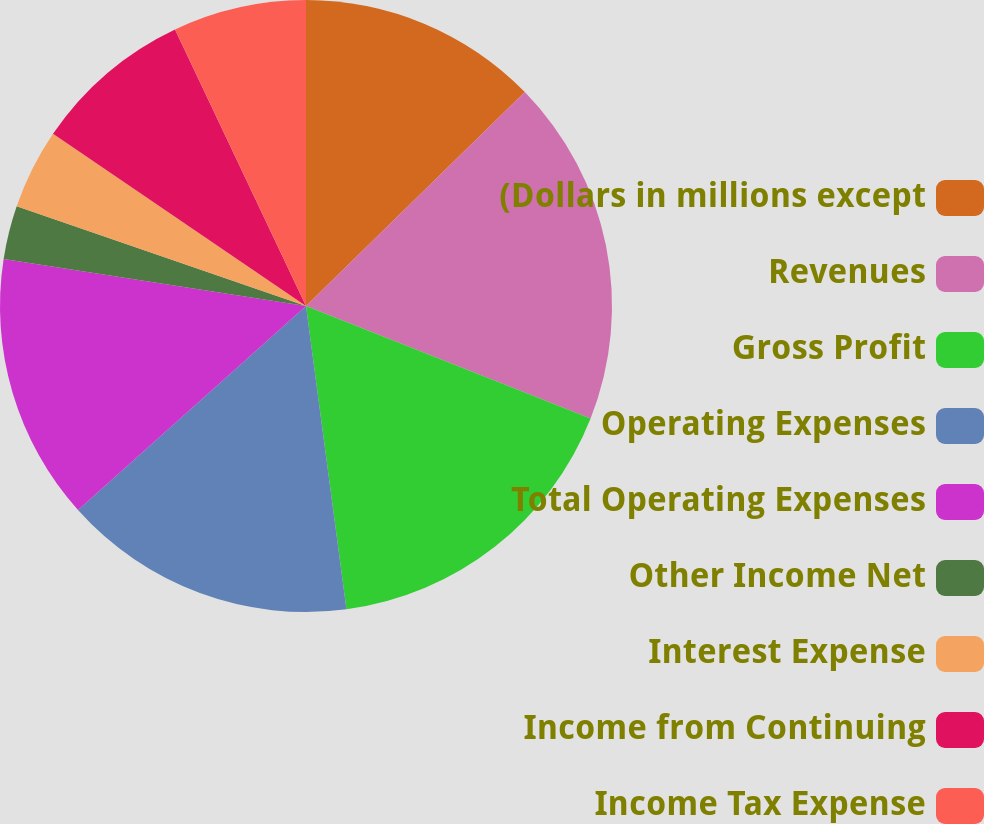Convert chart to OTSL. <chart><loc_0><loc_0><loc_500><loc_500><pie_chart><fcel>(Dollars in millions except<fcel>Revenues<fcel>Gross Profit<fcel>Operating Expenses<fcel>Total Operating Expenses<fcel>Other Income Net<fcel>Interest Expense<fcel>Income from Continuing<fcel>Income Tax Expense<nl><fcel>12.68%<fcel>18.31%<fcel>16.9%<fcel>15.49%<fcel>14.08%<fcel>2.82%<fcel>4.23%<fcel>8.45%<fcel>7.04%<nl></chart> 